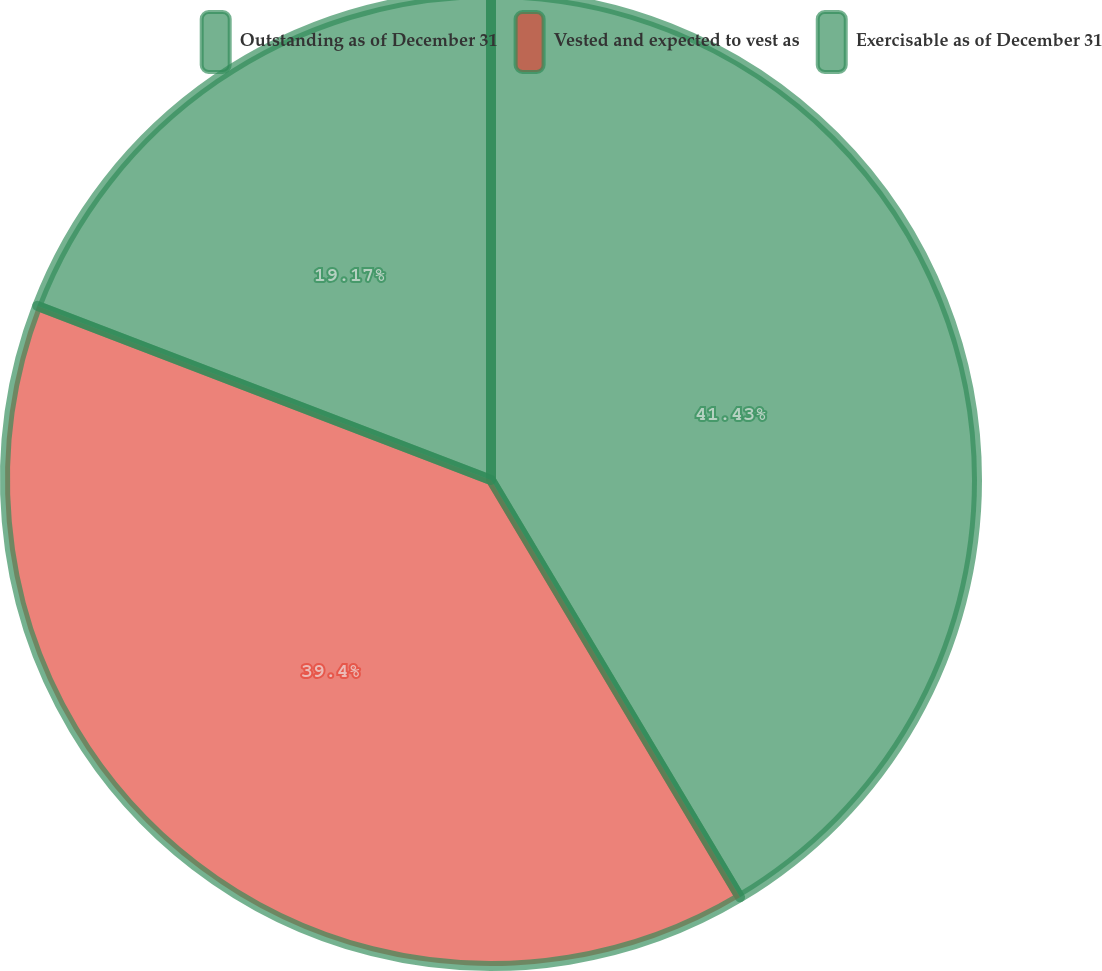<chart> <loc_0><loc_0><loc_500><loc_500><pie_chart><fcel>Outstanding as of December 31<fcel>Vested and expected to vest as<fcel>Exercisable as of December 31<nl><fcel>41.44%<fcel>39.4%<fcel>19.17%<nl></chart> 